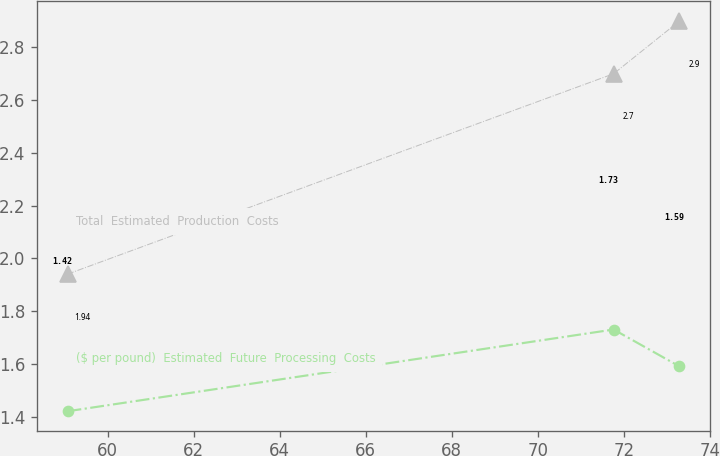Convert chart to OTSL. <chart><loc_0><loc_0><loc_500><loc_500><line_chart><ecel><fcel>($ per pound)  Estimated  Future  Processing  Costs<fcel>Total  Estimated  Production  Costs<nl><fcel>59.07<fcel>1.42<fcel>1.94<nl><fcel>71.76<fcel>1.73<fcel>2.7<nl><fcel>73.29<fcel>1.59<fcel>2.9<nl></chart> 